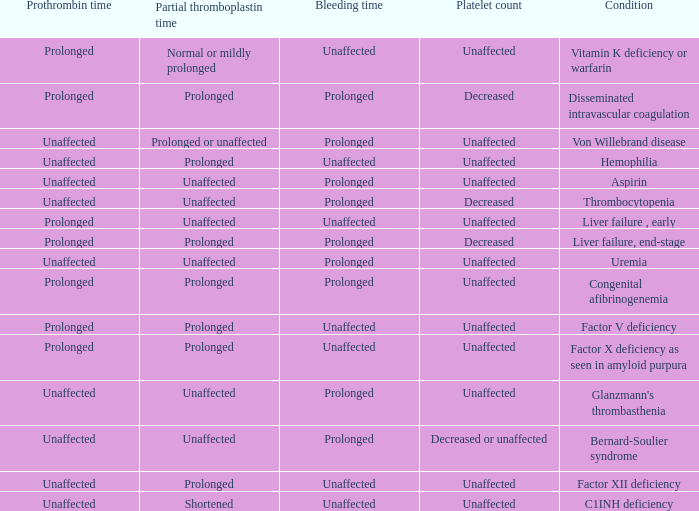Which Platelet count has a Condition of bernard-soulier syndrome? Decreased or unaffected. 